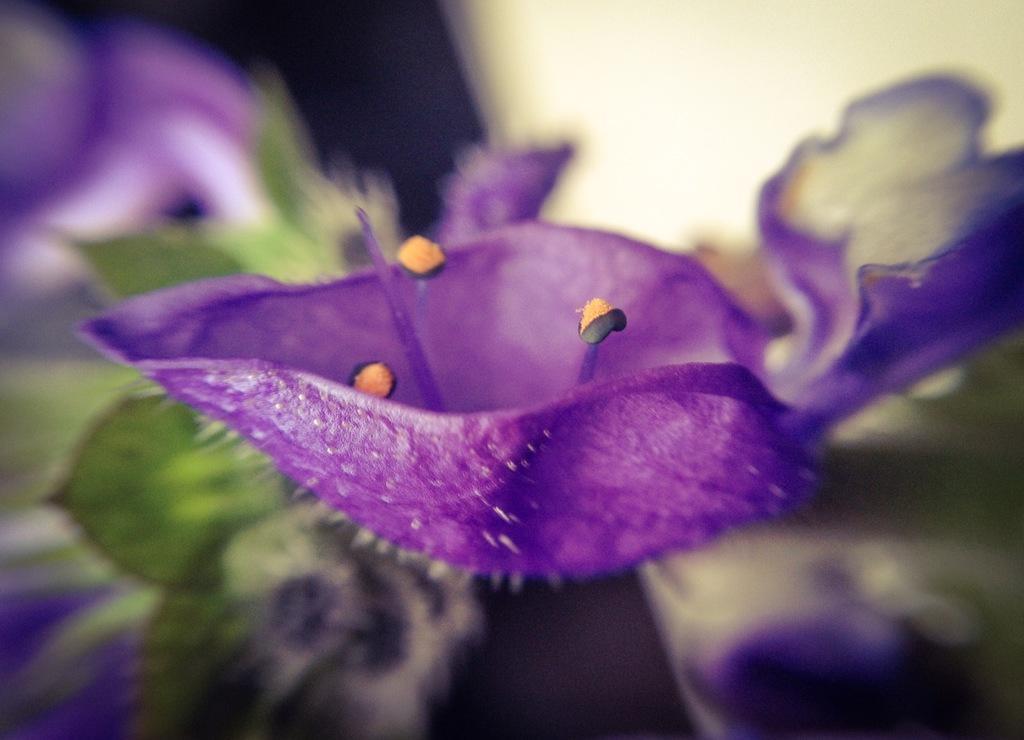How would you summarize this image in a sentence or two? In this image I can see the flowers to the plant. I can see these flowers are in purple and yellow color. And there is a blurred background. 